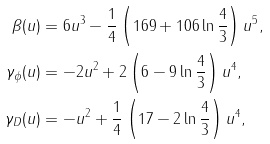Convert formula to latex. <formula><loc_0><loc_0><loc_500><loc_500>\beta ( u ) & = 6 u ^ { 3 } - \frac { 1 } { 4 } \left ( 1 6 9 + 1 0 6 \ln \frac { 4 } { 3 } \right ) u ^ { 5 } , \\ \gamma _ { \phi } ( u ) & = - 2 u ^ { 2 } + 2 \left ( 6 - 9 \ln \frac { 4 } { 3 } \right ) u ^ { 4 } , \\ \gamma _ { D } ( u ) & = - u ^ { 2 } + \frac { 1 } { 4 } \left ( 1 7 - 2 \ln \frac { 4 } { 3 } \right ) u ^ { 4 } ,</formula> 